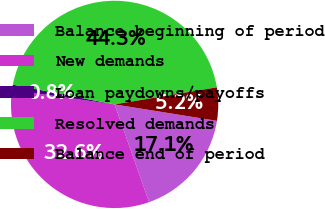Convert chart. <chart><loc_0><loc_0><loc_500><loc_500><pie_chart><fcel>Balance beginning of period<fcel>New demands<fcel>Loan paydowns/payoffs<fcel>Resolved demands<fcel>Balance end of period<nl><fcel>17.07%<fcel>32.62%<fcel>0.83%<fcel>44.32%<fcel>5.17%<nl></chart> 